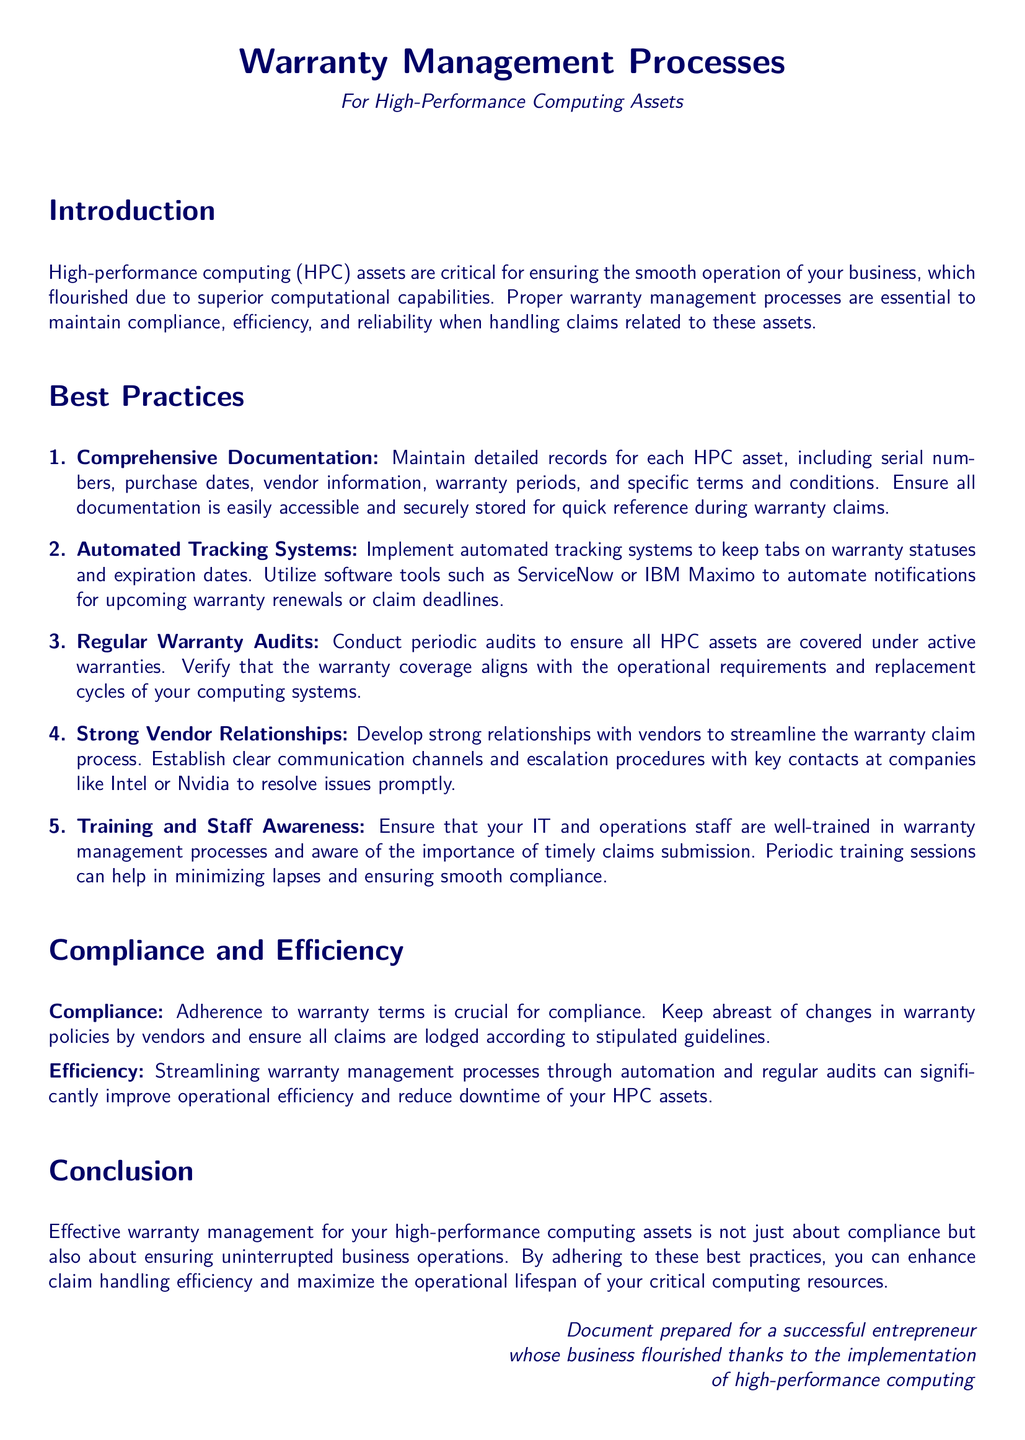What are the critical assets mentioned? The document refers specifically to high-performance computing assets as critical for business operations.
Answer: high-performance computing assets What is the purpose of warranty management processes? The introduction states that warranty management processes are essential to maintain compliance, efficiency, and reliability.
Answer: compliance, efficiency, and reliability How many best practices are listed? The document enumerates five best practices for managing warranty information.
Answer: five Which software tools are suggested for automating warranty tracking? The document mentions ServiceNow and IBM Maximo as tools for automation.
Answer: ServiceNow, IBM Maximo What is emphasized as important for staff regarding warranty management? The text highlights the importance of well-trained staff in warranty management processes.
Answer: training What is a necessary action to ensure compliance with warranty terms? The document specifies that adherence to warranty terms is crucial for compliance.
Answer: adherence What does conducting regular warranty audits help verify? The document states that audits help verify coverage alignment with operational requirements.
Answer: warranty coverage alignment Which relationship is emphasized to streamline claim processes? The document emphasizes developing strong relationships with vendors for efficient claim management.
Answer: vendor relationships What is the expected outcome of efficient warranty management? The conclusion states that effective warranty management enhances claim handling efficiency.
Answer: enhance claim handling efficiency 